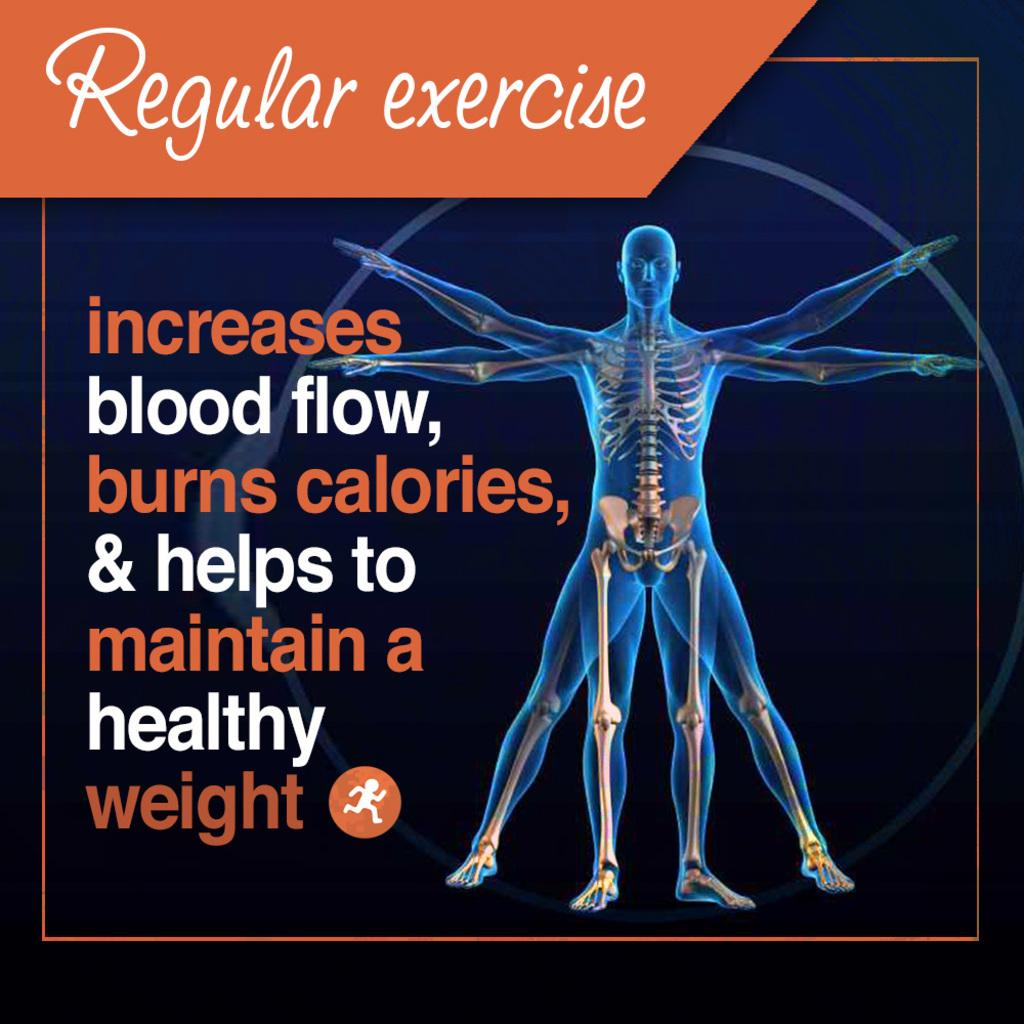<image>
Render a clear and concise summary of the photo. Poster showing a man's skeleton body next to the words "Regular Exercise". 